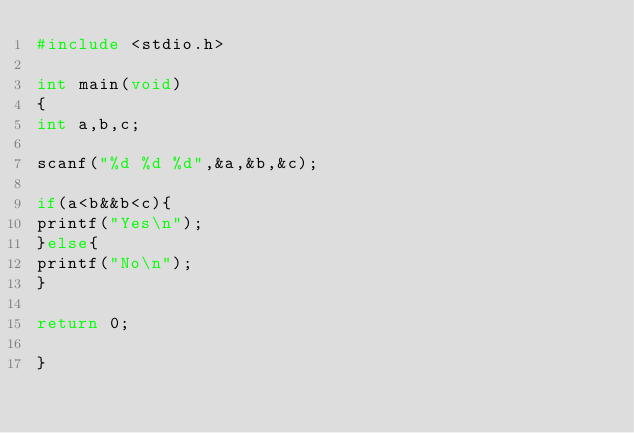Convert code to text. <code><loc_0><loc_0><loc_500><loc_500><_C_>#include <stdio.h>

int main(void)
{
int a,b,c;

scanf("%d %d %d",&a,&b,&c);

if(a<b&&b<c){
printf("Yes\n");
}else{
printf("No\n");
}

return 0;

}</code> 